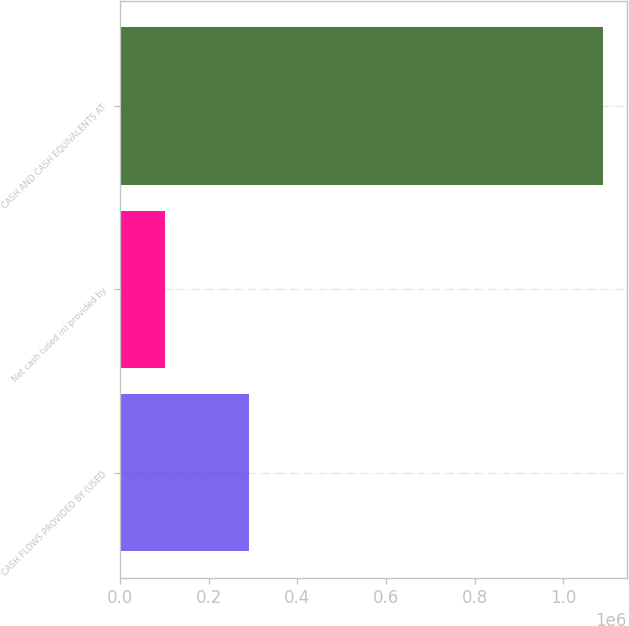<chart> <loc_0><loc_0><loc_500><loc_500><bar_chart><fcel>CASH FLOWS PROVIDED BY (USED<fcel>Net cash (used in) provided by<fcel>CASH AND CASH EQUIVALENTS AT<nl><fcel>291081<fcel>100689<fcel>1.0893e+06<nl></chart> 